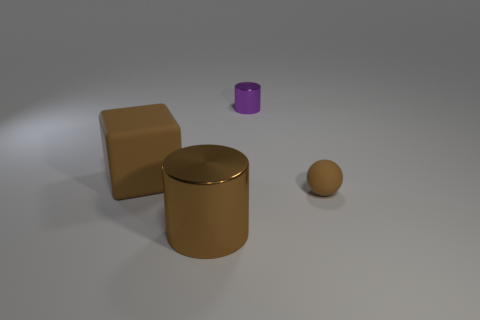Add 1 tiny brown blocks. How many objects exist? 5 Subtract all cubes. How many objects are left? 3 Add 3 large brown blocks. How many large brown blocks are left? 4 Add 1 purple objects. How many purple objects exist? 2 Subtract 0 purple spheres. How many objects are left? 4 Subtract all purple balls. Subtract all big metal cylinders. How many objects are left? 3 